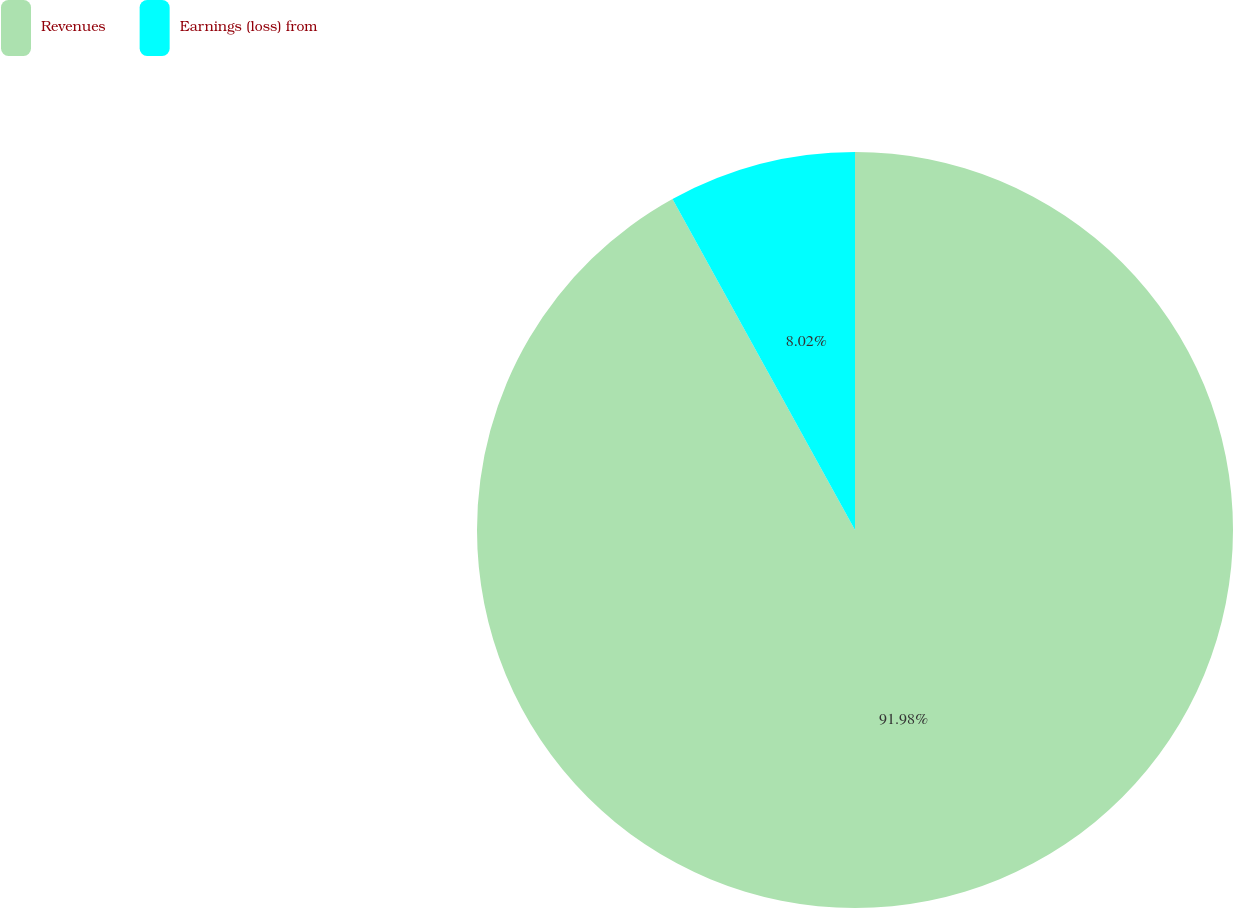Convert chart to OTSL. <chart><loc_0><loc_0><loc_500><loc_500><pie_chart><fcel>Revenues<fcel>Earnings (loss) from<nl><fcel>91.98%<fcel>8.02%<nl></chart> 